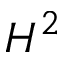Convert formula to latex. <formula><loc_0><loc_0><loc_500><loc_500>H ^ { 2 }</formula> 